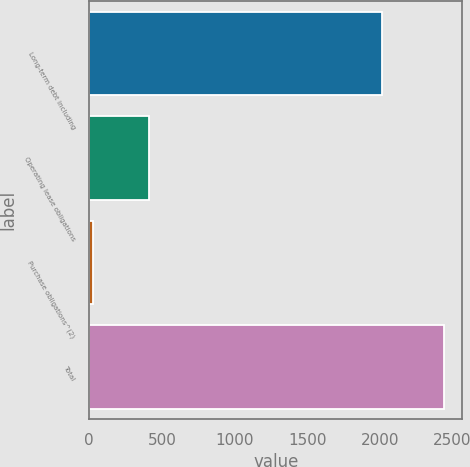Convert chart to OTSL. <chart><loc_0><loc_0><loc_500><loc_500><bar_chart><fcel>Long-term debt including<fcel>Operating lease obligations<fcel>Purchase obligations^(2)<fcel>Total<nl><fcel>2012<fcel>409<fcel>24<fcel>2445<nl></chart> 